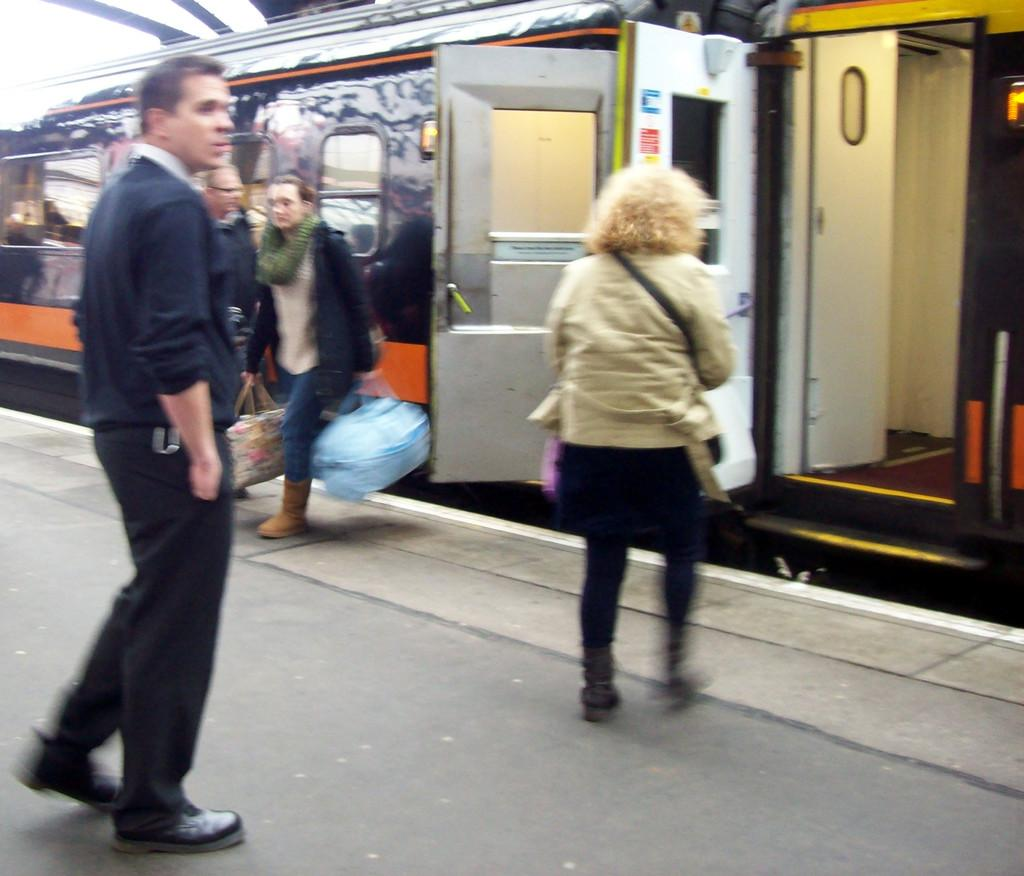Who or what can be seen in the image? There are people in the image. What are some of the people holding? Some people are holding bags. What is the main mode of transportation in the image? There is a train in the image. What features does the train have? The train has doors and windows. Where is the train located? There is a platform in the image. What type of polish is being applied to the train in the image? There is no indication in the image that any polish is being applied to the train. What kind of breakfast is being served to the people in the image? There is no breakfast visible in the image. 